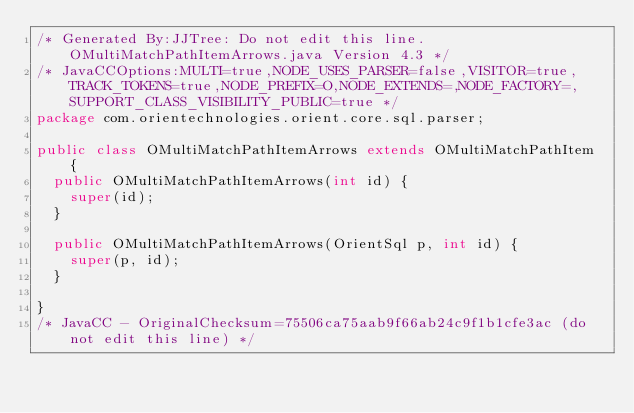<code> <loc_0><loc_0><loc_500><loc_500><_Java_>/* Generated By:JJTree: Do not edit this line. OMultiMatchPathItemArrows.java Version 4.3 */
/* JavaCCOptions:MULTI=true,NODE_USES_PARSER=false,VISITOR=true,TRACK_TOKENS=true,NODE_PREFIX=O,NODE_EXTENDS=,NODE_FACTORY=,SUPPORT_CLASS_VISIBILITY_PUBLIC=true */
package com.orientechnologies.orient.core.sql.parser;

public class OMultiMatchPathItemArrows extends OMultiMatchPathItem {
  public OMultiMatchPathItemArrows(int id) {
    super(id);
  }

  public OMultiMatchPathItemArrows(OrientSql p, int id) {
    super(p, id);
  }

}
/* JavaCC - OriginalChecksum=75506ca75aab9f66ab24c9f1b1cfe3ac (do not edit this line) */
</code> 